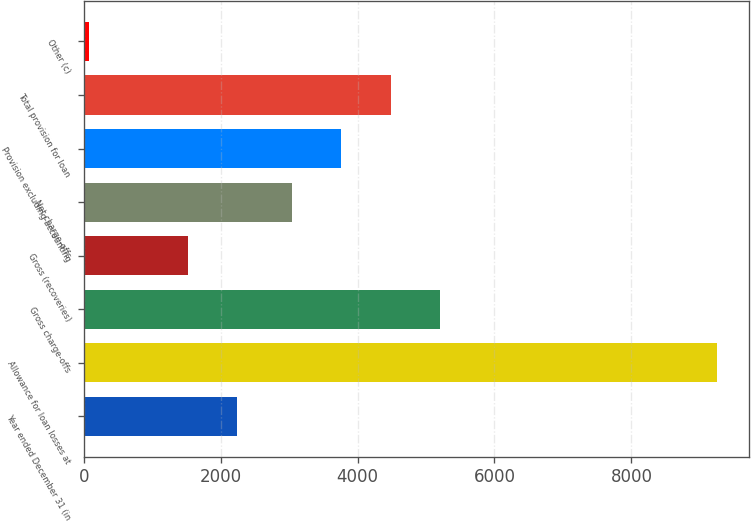Convert chart to OTSL. <chart><loc_0><loc_0><loc_500><loc_500><bar_chart><fcel>Year ended December 31 (in<fcel>Allowance for loan losses at<fcel>Gross charge-offs<fcel>Gross (recoveries)<fcel>Net charge-offs<fcel>Provision excluding accounting<fcel>Total provision for loan<fcel>Other (c)<nl><fcel>2238.3<fcel>9250.3<fcel>5202.3<fcel>1518.2<fcel>3042<fcel>3762.1<fcel>4482.2<fcel>78<nl></chart> 